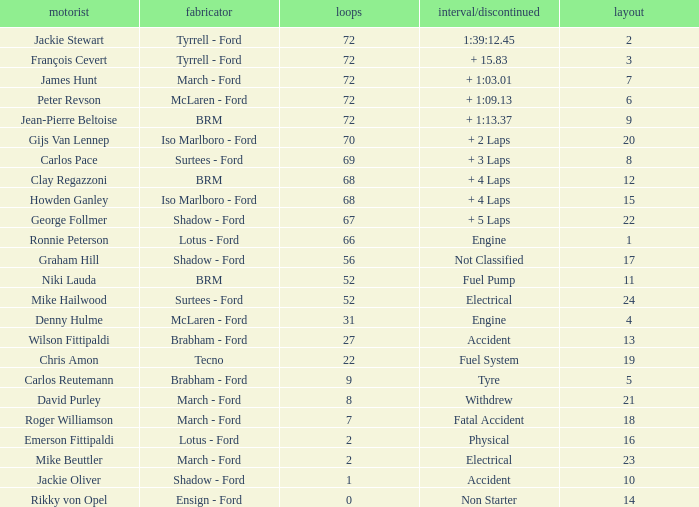What is the top lap that had a tyre time? 9.0. 